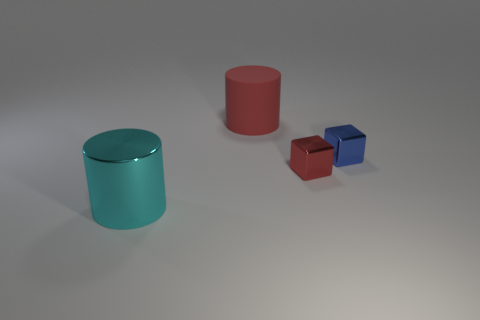Could these objects be part of a larger set or collection? Yes, given their consistent material finish and varied colors and sizes, these objects might belong to a set that is designed to either display an array of colors or sizes or demonstrate some principles of volume and geometry. 